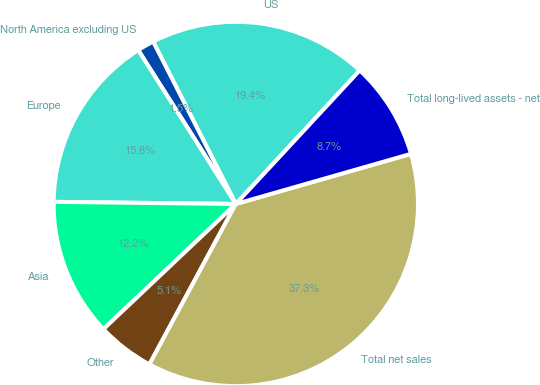<chart> <loc_0><loc_0><loc_500><loc_500><pie_chart><fcel>US<fcel>North America excluding US<fcel>Europe<fcel>Asia<fcel>Other<fcel>Total net sales<fcel>Total long-lived assets - net<nl><fcel>19.4%<fcel>1.5%<fcel>15.82%<fcel>12.24%<fcel>5.08%<fcel>37.3%<fcel>8.66%<nl></chart> 